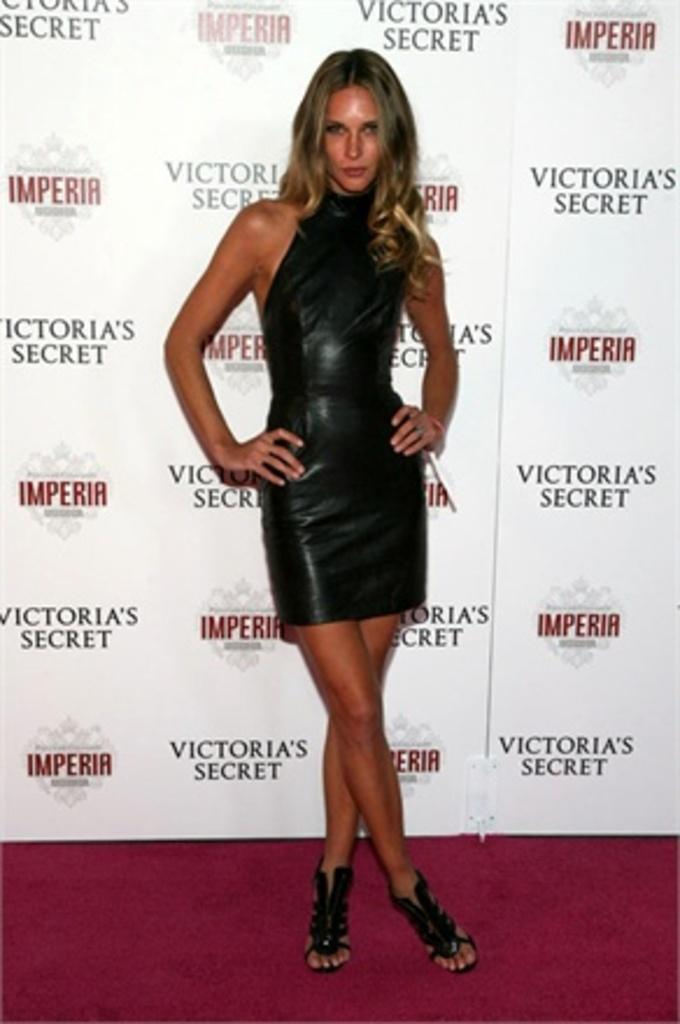Who is the main subject in the image? There is a woman in the image. What is the woman doing in the image? The woman is standing. What is the woman wearing in the image? The woman is wearing a black dress. What can be seen in the background of the image? There are logos and text visible in the background of the image. What type of nerve is being stimulated by the woman in the image? There is no indication in the image that the woman is stimulating any nerves, so it cannot be determined from the picture. 